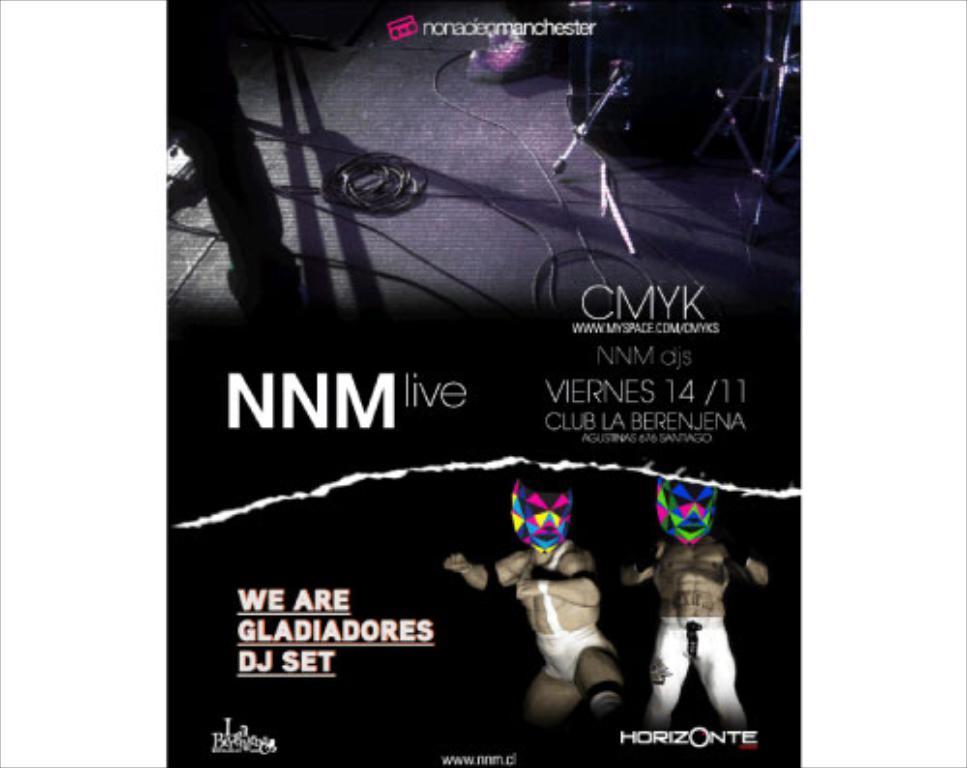Describe this image in one or two sentences. In the picture I can see the poster. On the poster I can see two persons on the bottom right side and there is a mask on their face. These are looking like cables on the floor. 